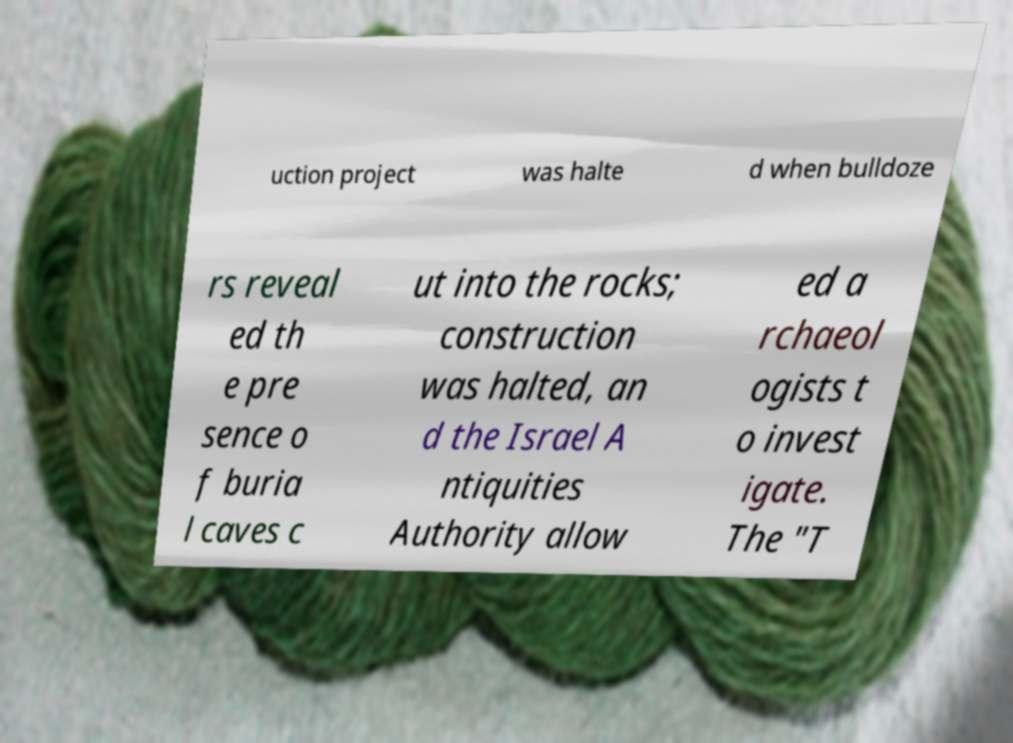I need the written content from this picture converted into text. Can you do that? uction project was halte d when bulldoze rs reveal ed th e pre sence o f buria l caves c ut into the rocks; construction was halted, an d the Israel A ntiquities Authority allow ed a rchaeol ogists t o invest igate. The "T 